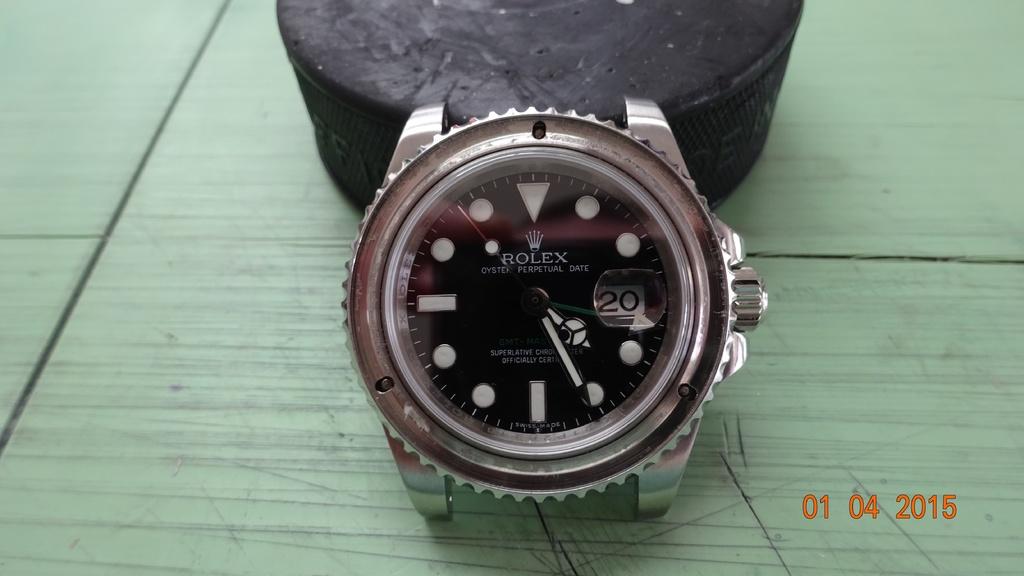What brand is the watch?
Keep it short and to the point. Rolex. What number is displayed on the watch?
Offer a very short reply. 20. 